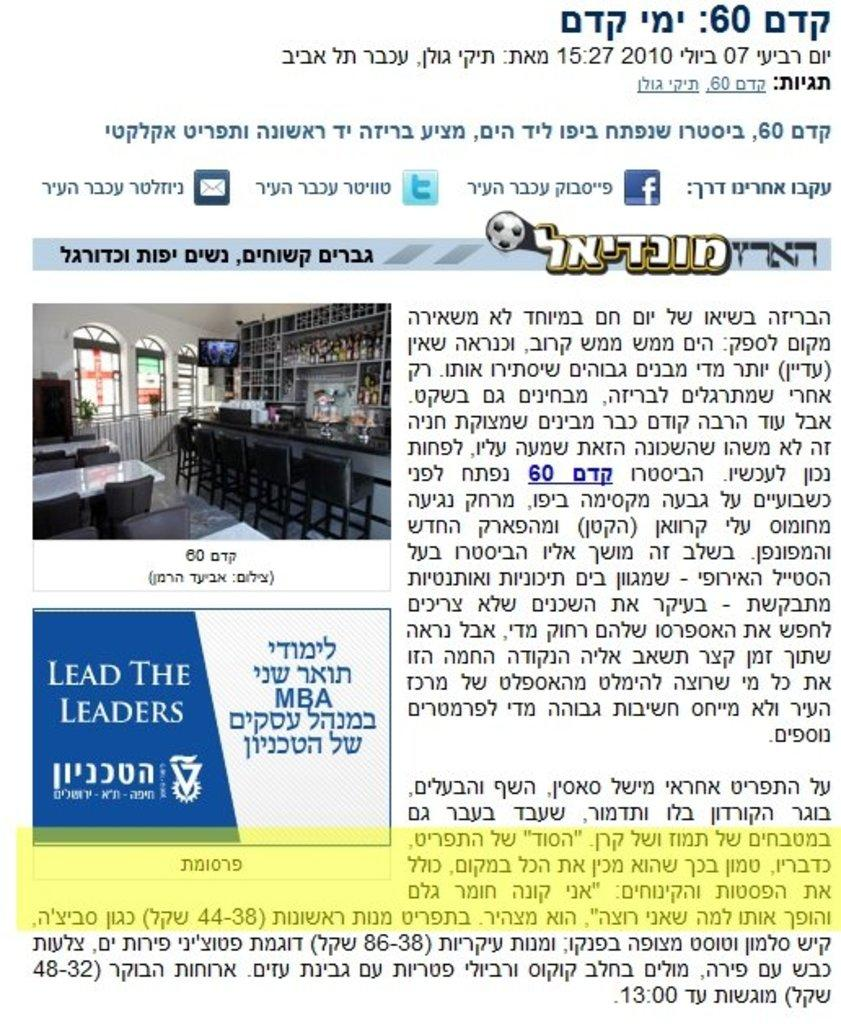<image>
Offer a succinct explanation of the picture presented. A poster in an arabic language advertising for Lead the Leaders. 